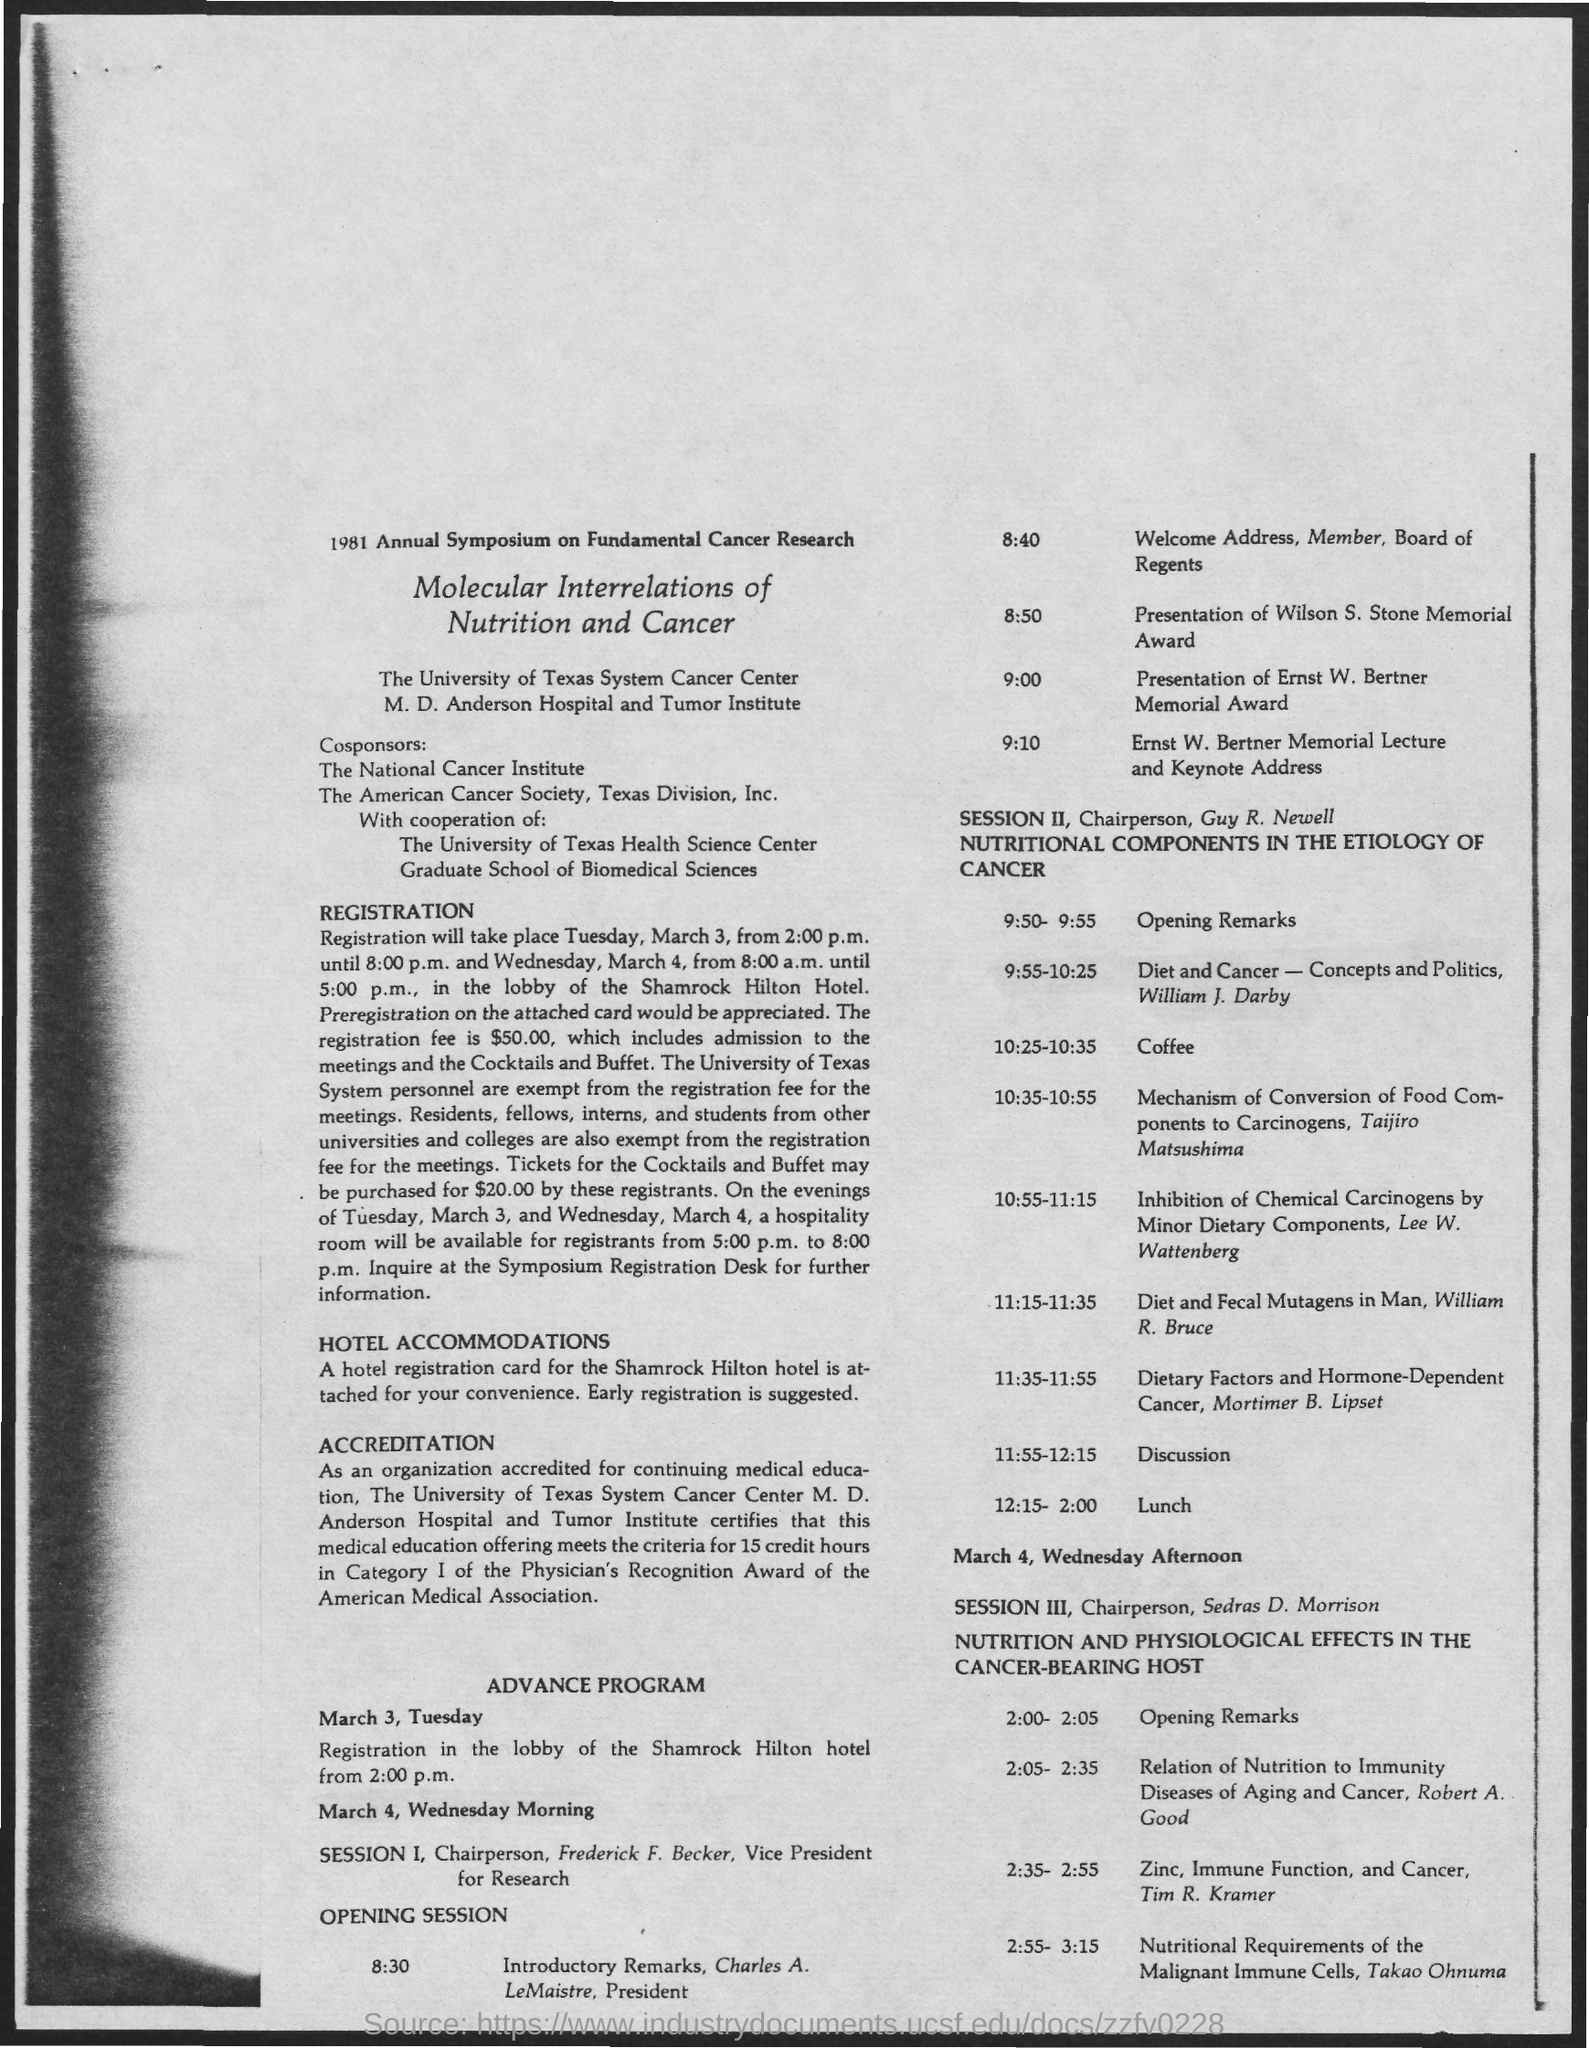Give some essential details in this illustration. Charles A. Le Maistre is designated as the President. According to the given page, Guy R. Newell is the chairperson for Session II. The chairperson for Session III, as mentioned on the given page, is Sedras D. Morrison. The schedule at the time of 12:15 - 2:00 in session 2 is lunch. The opening session is scheduled to begin at 8:30 as mentioned in the given schedule. 